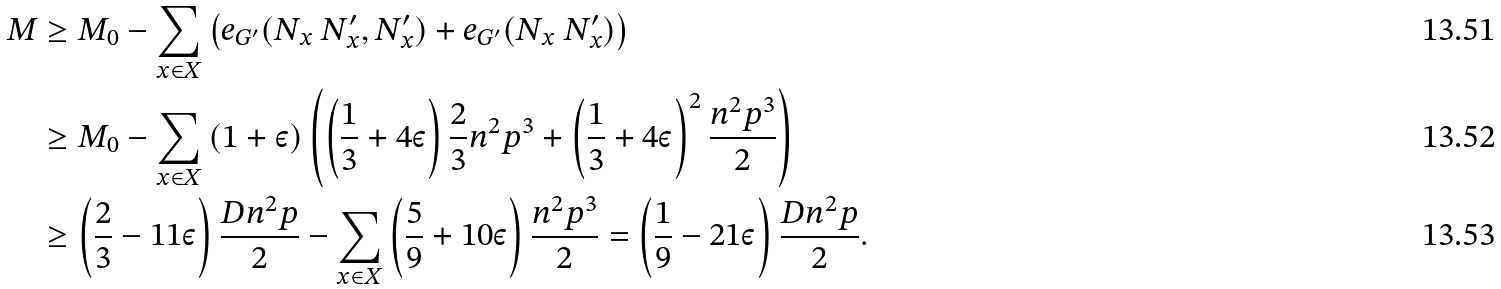Convert formula to latex. <formula><loc_0><loc_0><loc_500><loc_500>M & \geq M _ { 0 } - \sum _ { x \in X } \left ( e _ { G ^ { \prime } } ( N _ { x } \ N _ { x } ^ { \prime } , N _ { x } ^ { \prime } ) + e _ { G ^ { \prime } } ( N _ { x } \ N _ { x } ^ { \prime } ) \right ) \\ & \geq M _ { 0 } - \sum _ { x \in X } \left ( 1 + \varepsilon \right ) \left ( \left ( \frac { 1 } { 3 } + 4 \varepsilon \right ) \frac { 2 } { 3 } n ^ { 2 } p ^ { 3 } + \left ( \frac { 1 } { 3 } + 4 \varepsilon \right ) ^ { 2 } \frac { n ^ { 2 } p ^ { 3 } } { 2 } \right ) \\ & \geq \left ( \frac { 2 } { 3 } - 1 1 \varepsilon \right ) \frac { D n ^ { 2 } p } { 2 } - \sum _ { x \in X } \left ( \frac { 5 } { 9 } + 1 0 \varepsilon \right ) \frac { n ^ { 2 } p ^ { 3 } } { 2 } = \left ( \frac { 1 } { 9 } - 2 1 \varepsilon \right ) \frac { D n ^ { 2 } p } { 2 } .</formula> 